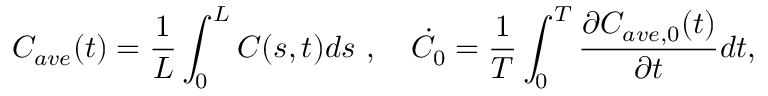<formula> <loc_0><loc_0><loc_500><loc_500>C _ { a v e } ( t ) = \frac { 1 } { L } \int _ { 0 } ^ { L } C ( s , t ) d s , \dot { C _ { 0 } } = \frac { 1 } { T } \int _ { 0 } ^ { T } \frac { \partial C _ { a v e , 0 } ( t ) } { \partial t } d t ,</formula> 